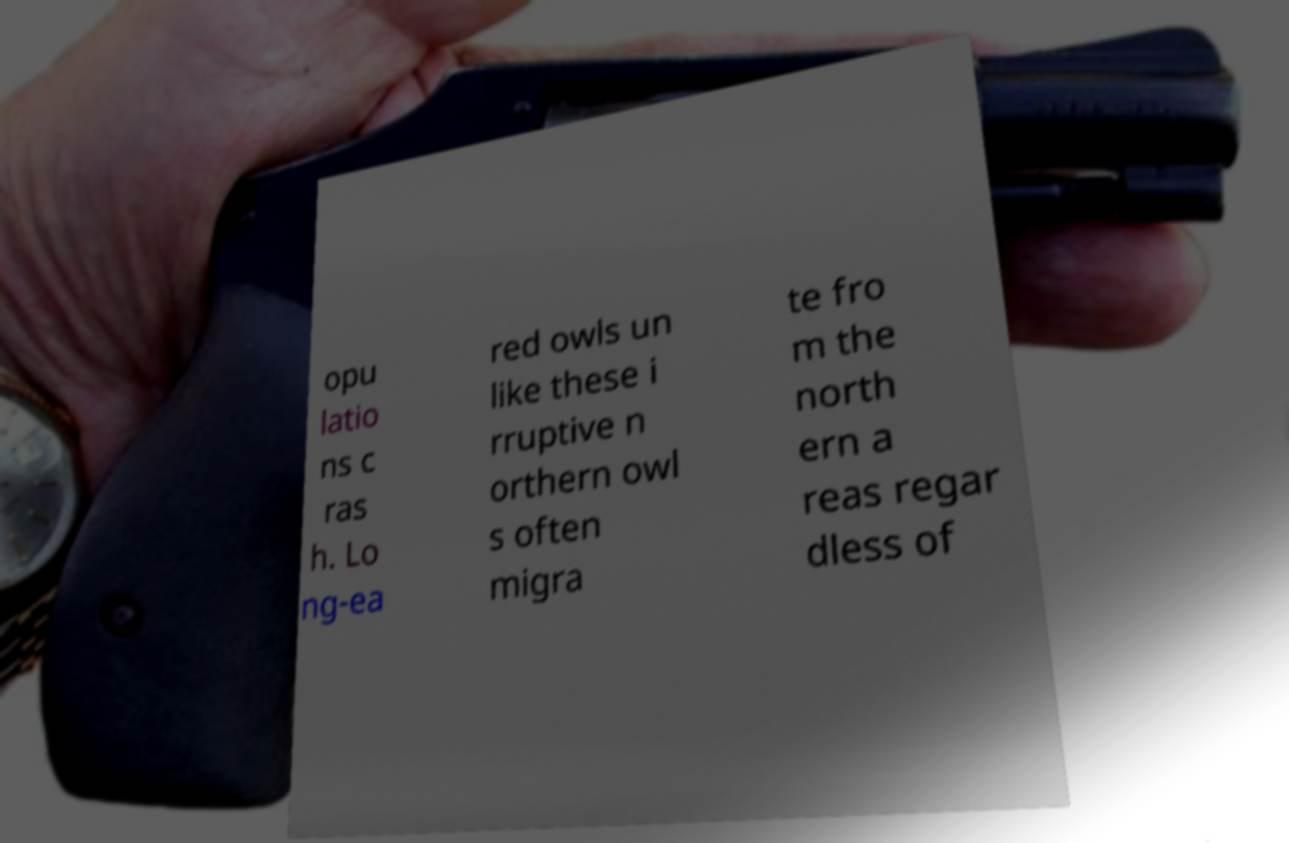I need the written content from this picture converted into text. Can you do that? opu latio ns c ras h. Lo ng-ea red owls un like these i rruptive n orthern owl s often migra te fro m the north ern a reas regar dless of 